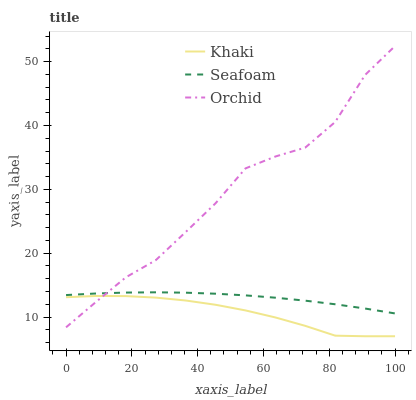Does Khaki have the minimum area under the curve?
Answer yes or no. Yes. Does Orchid have the maximum area under the curve?
Answer yes or no. Yes. Does Seafoam have the minimum area under the curve?
Answer yes or no. No. Does Seafoam have the maximum area under the curve?
Answer yes or no. No. Is Seafoam the smoothest?
Answer yes or no. Yes. Is Orchid the roughest?
Answer yes or no. Yes. Is Orchid the smoothest?
Answer yes or no. No. Is Seafoam the roughest?
Answer yes or no. No. Does Orchid have the lowest value?
Answer yes or no. No. Does Orchid have the highest value?
Answer yes or no. Yes. Does Seafoam have the highest value?
Answer yes or no. No. Is Khaki less than Seafoam?
Answer yes or no. Yes. Is Seafoam greater than Khaki?
Answer yes or no. Yes. Does Seafoam intersect Orchid?
Answer yes or no. Yes. Is Seafoam less than Orchid?
Answer yes or no. No. Is Seafoam greater than Orchid?
Answer yes or no. No. Does Khaki intersect Seafoam?
Answer yes or no. No. 